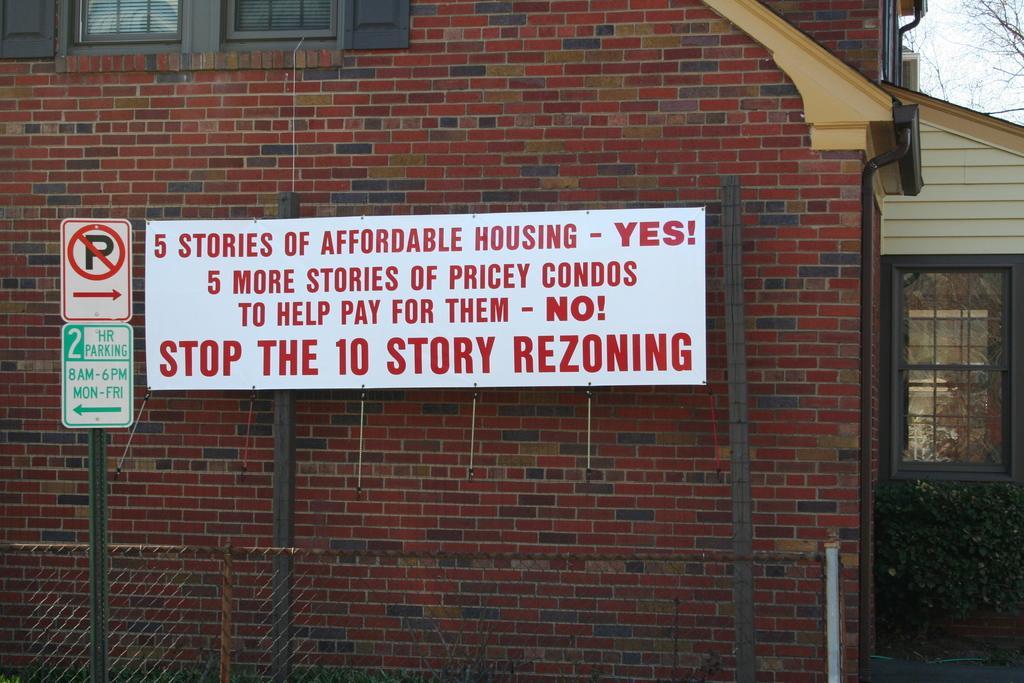Could you give a brief overview of what you see in this image? In this image we can see a house. There is a board on which some text written on it. There is a traffic sign board in the image. There is a tree and a plant in the image. 